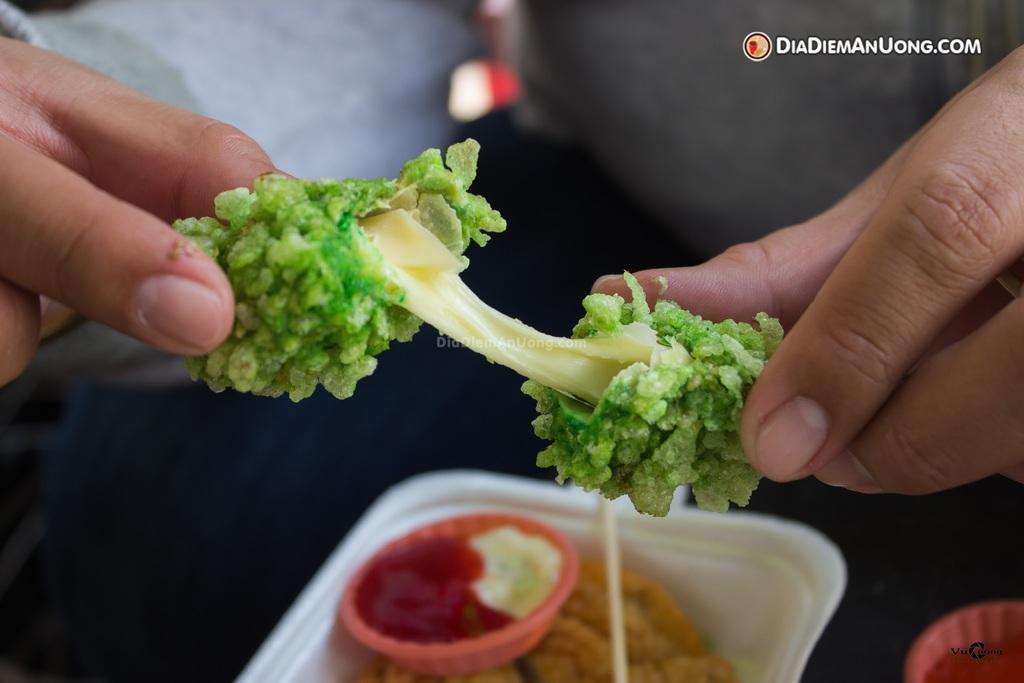How would you summarize this image in a sentence or two? In the picture a person is holding some food item with his hands and below that in a white box there is some other food item and sauces. 